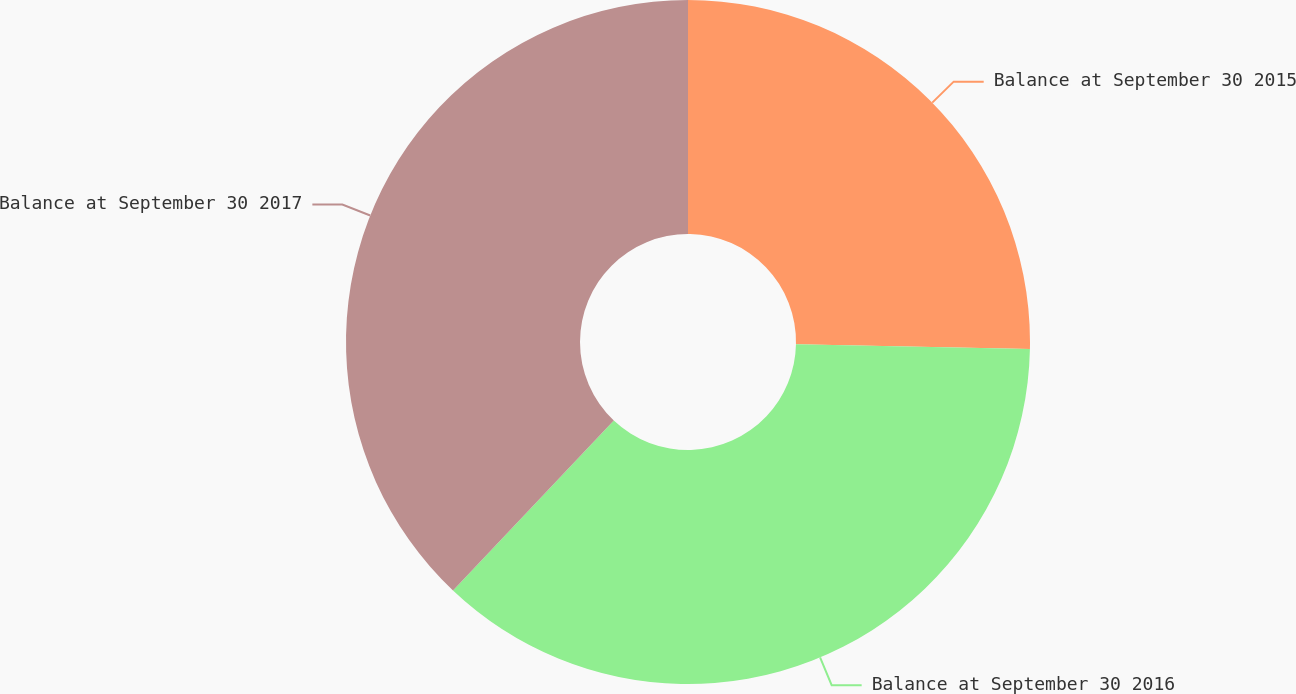<chart> <loc_0><loc_0><loc_500><loc_500><pie_chart><fcel>Balance at September 30 2015<fcel>Balance at September 30 2016<fcel>Balance at September 30 2017<nl><fcel>25.32%<fcel>36.73%<fcel>37.94%<nl></chart> 